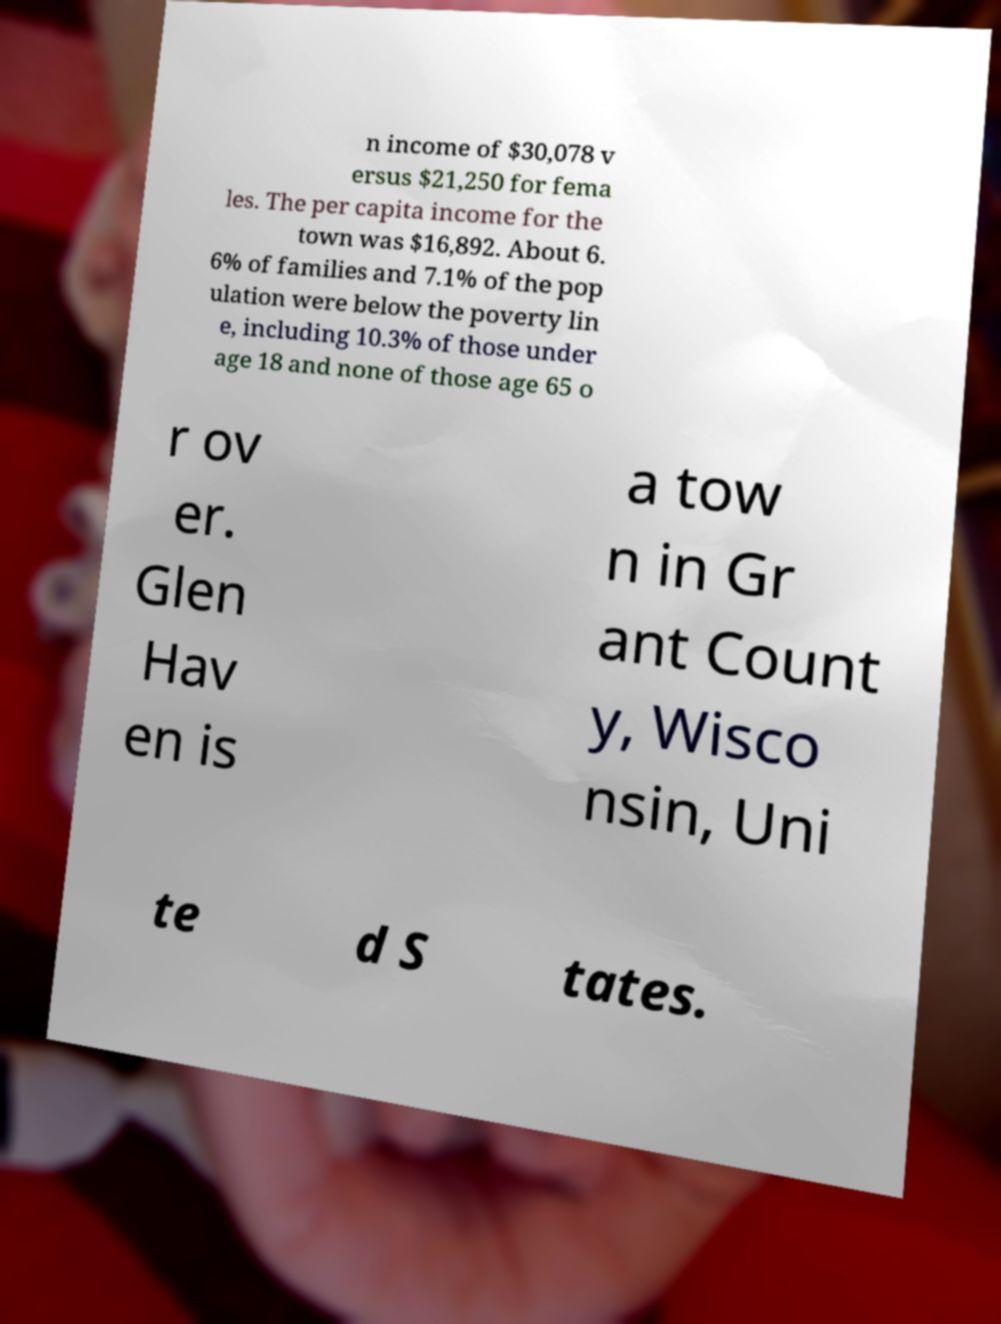Could you extract and type out the text from this image? n income of $30,078 v ersus $21,250 for fema les. The per capita income for the town was $16,892. About 6. 6% of families and 7.1% of the pop ulation were below the poverty lin e, including 10.3% of those under age 18 and none of those age 65 o r ov er. Glen Hav en is a tow n in Gr ant Count y, Wisco nsin, Uni te d S tates. 